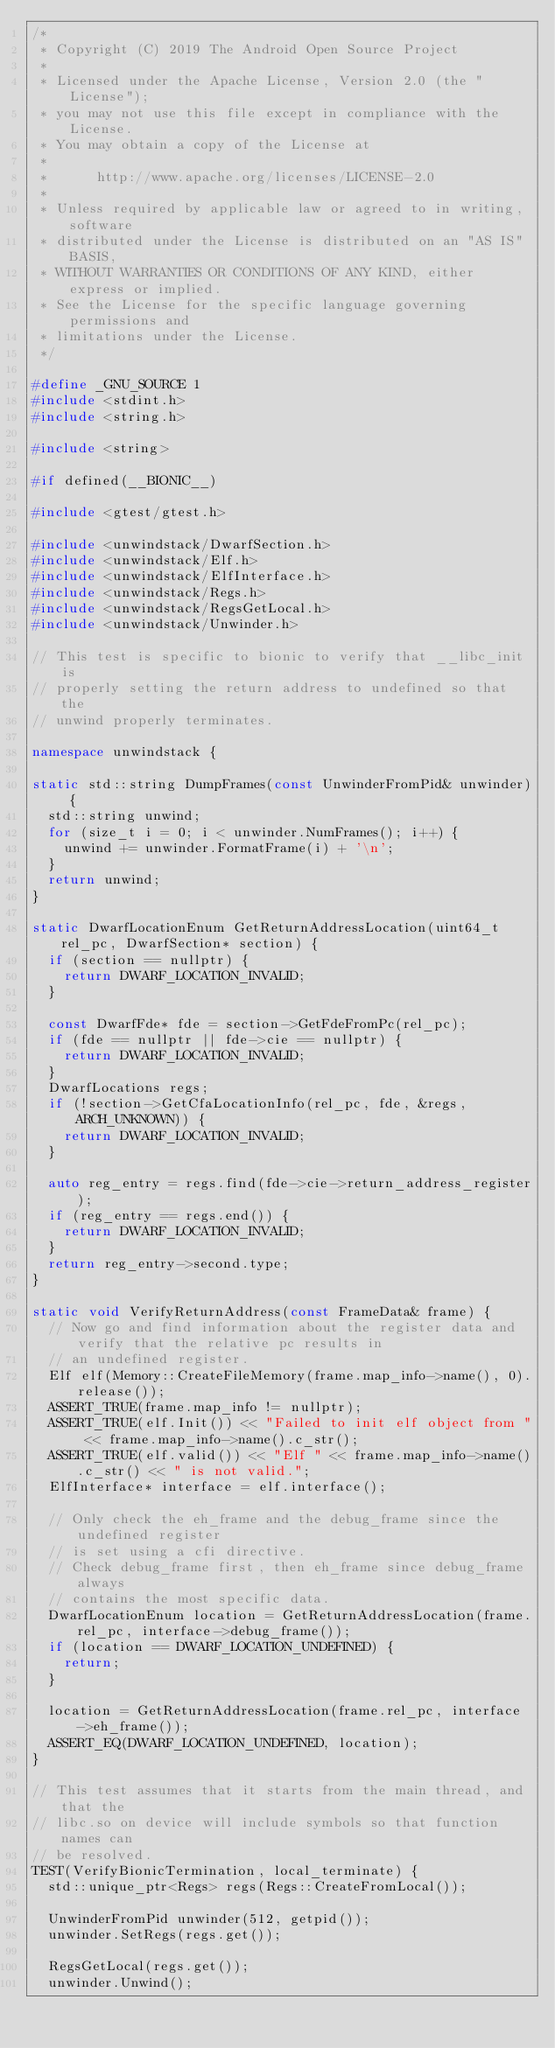<code> <loc_0><loc_0><loc_500><loc_500><_C++_>/*
 * Copyright (C) 2019 The Android Open Source Project
 *
 * Licensed under the Apache License, Version 2.0 (the "License");
 * you may not use this file except in compliance with the License.
 * You may obtain a copy of the License at
 *
 *      http://www.apache.org/licenses/LICENSE-2.0
 *
 * Unless required by applicable law or agreed to in writing, software
 * distributed under the License is distributed on an "AS IS" BASIS,
 * WITHOUT WARRANTIES OR CONDITIONS OF ANY KIND, either express or implied.
 * See the License for the specific language governing permissions and
 * limitations under the License.
 */

#define _GNU_SOURCE 1
#include <stdint.h>
#include <string.h>

#include <string>

#if defined(__BIONIC__)

#include <gtest/gtest.h>

#include <unwindstack/DwarfSection.h>
#include <unwindstack/Elf.h>
#include <unwindstack/ElfInterface.h>
#include <unwindstack/Regs.h>
#include <unwindstack/RegsGetLocal.h>
#include <unwindstack/Unwinder.h>

// This test is specific to bionic to verify that __libc_init is
// properly setting the return address to undefined so that the
// unwind properly terminates.

namespace unwindstack {

static std::string DumpFrames(const UnwinderFromPid& unwinder) {
  std::string unwind;
  for (size_t i = 0; i < unwinder.NumFrames(); i++) {
    unwind += unwinder.FormatFrame(i) + '\n';
  }
  return unwind;
}

static DwarfLocationEnum GetReturnAddressLocation(uint64_t rel_pc, DwarfSection* section) {
  if (section == nullptr) {
    return DWARF_LOCATION_INVALID;
  }

  const DwarfFde* fde = section->GetFdeFromPc(rel_pc);
  if (fde == nullptr || fde->cie == nullptr) {
    return DWARF_LOCATION_INVALID;
  }
  DwarfLocations regs;
  if (!section->GetCfaLocationInfo(rel_pc, fde, &regs, ARCH_UNKNOWN)) {
    return DWARF_LOCATION_INVALID;
  }

  auto reg_entry = regs.find(fde->cie->return_address_register);
  if (reg_entry == regs.end()) {
    return DWARF_LOCATION_INVALID;
  }
  return reg_entry->second.type;
}

static void VerifyReturnAddress(const FrameData& frame) {
  // Now go and find information about the register data and verify that the relative pc results in
  // an undefined register.
  Elf elf(Memory::CreateFileMemory(frame.map_info->name(), 0).release());
  ASSERT_TRUE(frame.map_info != nullptr);
  ASSERT_TRUE(elf.Init()) << "Failed to init elf object from " << frame.map_info->name().c_str();
  ASSERT_TRUE(elf.valid()) << "Elf " << frame.map_info->name().c_str() << " is not valid.";
  ElfInterface* interface = elf.interface();

  // Only check the eh_frame and the debug_frame since the undefined register
  // is set using a cfi directive.
  // Check debug_frame first, then eh_frame since debug_frame always
  // contains the most specific data.
  DwarfLocationEnum location = GetReturnAddressLocation(frame.rel_pc, interface->debug_frame());
  if (location == DWARF_LOCATION_UNDEFINED) {
    return;
  }

  location = GetReturnAddressLocation(frame.rel_pc, interface->eh_frame());
  ASSERT_EQ(DWARF_LOCATION_UNDEFINED, location);
}

// This test assumes that it starts from the main thread, and that the
// libc.so on device will include symbols so that function names can
// be resolved.
TEST(VerifyBionicTermination, local_terminate) {
  std::unique_ptr<Regs> regs(Regs::CreateFromLocal());

  UnwinderFromPid unwinder(512, getpid());
  unwinder.SetRegs(regs.get());

  RegsGetLocal(regs.get());
  unwinder.Unwind();</code> 